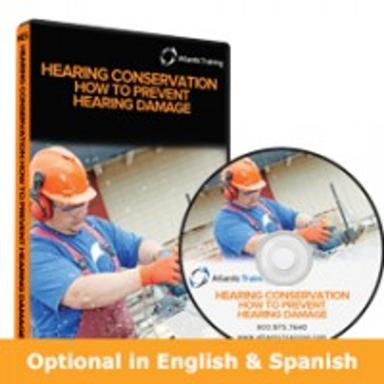What is the main topic of the DVD? The main topic of the DVD is Hearing Conservation, specifically focusing on educational strategies on how to prevent hearing damage in noisy work environments, such as those experienced by the person shown using heavy machinery on the cover. 